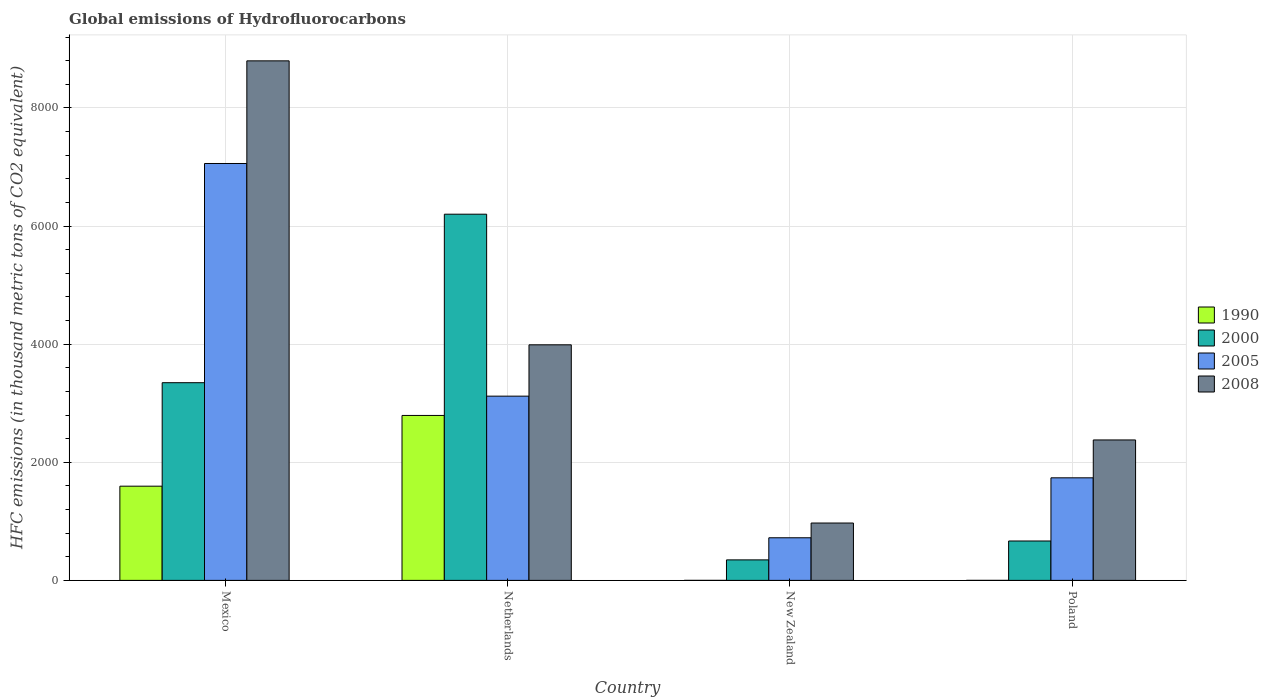How many groups of bars are there?
Offer a very short reply. 4. How many bars are there on the 2nd tick from the left?
Provide a short and direct response. 4. What is the label of the 3rd group of bars from the left?
Ensure brevity in your answer.  New Zealand. What is the global emissions of Hydrofluorocarbons in 2005 in Mexico?
Your answer should be very brief. 7058.9. Across all countries, what is the maximum global emissions of Hydrofluorocarbons in 1990?
Provide a succinct answer. 2792.9. Across all countries, what is the minimum global emissions of Hydrofluorocarbons in 2008?
Your answer should be compact. 971.4. What is the total global emissions of Hydrofluorocarbons in 2008 in the graph?
Your answer should be very brief. 1.61e+04. What is the difference between the global emissions of Hydrofluorocarbons in 2000 in Netherlands and that in New Zealand?
Make the answer very short. 5853.1. What is the difference between the global emissions of Hydrofluorocarbons in 2005 in Poland and the global emissions of Hydrofluorocarbons in 2000 in Mexico?
Your response must be concise. -1610.6. What is the average global emissions of Hydrofluorocarbons in 2008 per country?
Your response must be concise. 4033.78. What is the difference between the global emissions of Hydrofluorocarbons of/in 1990 and global emissions of Hydrofluorocarbons of/in 2008 in Mexico?
Your answer should be very brief. -7201.6. What is the ratio of the global emissions of Hydrofluorocarbons in 2005 in Mexico to that in Poland?
Ensure brevity in your answer.  4.06. Is the global emissions of Hydrofluorocarbons in 2008 in Netherlands less than that in Poland?
Your response must be concise. No. Is the difference between the global emissions of Hydrofluorocarbons in 1990 in Netherlands and Poland greater than the difference between the global emissions of Hydrofluorocarbons in 2008 in Netherlands and Poland?
Offer a very short reply. Yes. What is the difference between the highest and the second highest global emissions of Hydrofluorocarbons in 2008?
Provide a short and direct response. 1610.8. What is the difference between the highest and the lowest global emissions of Hydrofluorocarbons in 2005?
Offer a very short reply. 6337.2. What does the 1st bar from the left in Netherlands represents?
Offer a very short reply. 1990. What does the 4th bar from the right in New Zealand represents?
Give a very brief answer. 1990. Is it the case that in every country, the sum of the global emissions of Hydrofluorocarbons in 2000 and global emissions of Hydrofluorocarbons in 1990 is greater than the global emissions of Hydrofluorocarbons in 2005?
Provide a short and direct response. No. Are all the bars in the graph horizontal?
Your answer should be compact. No. How many countries are there in the graph?
Your answer should be compact. 4. What is the difference between two consecutive major ticks on the Y-axis?
Offer a terse response. 2000. Does the graph contain any zero values?
Make the answer very short. No. Where does the legend appear in the graph?
Provide a succinct answer. Center right. How many legend labels are there?
Give a very brief answer. 4. How are the legend labels stacked?
Your answer should be very brief. Vertical. What is the title of the graph?
Your answer should be compact. Global emissions of Hydrofluorocarbons. What is the label or title of the X-axis?
Provide a short and direct response. Country. What is the label or title of the Y-axis?
Give a very brief answer. HFC emissions (in thousand metric tons of CO2 equivalent). What is the HFC emissions (in thousand metric tons of CO2 equivalent) in 1990 in Mexico?
Your answer should be compact. 1595.3. What is the HFC emissions (in thousand metric tons of CO2 equivalent) in 2000 in Mexico?
Provide a succinct answer. 3347.3. What is the HFC emissions (in thousand metric tons of CO2 equivalent) of 2005 in Mexico?
Give a very brief answer. 7058.9. What is the HFC emissions (in thousand metric tons of CO2 equivalent) of 2008 in Mexico?
Give a very brief answer. 8796.9. What is the HFC emissions (in thousand metric tons of CO2 equivalent) in 1990 in Netherlands?
Ensure brevity in your answer.  2792.9. What is the HFC emissions (in thousand metric tons of CO2 equivalent) of 2000 in Netherlands?
Provide a short and direct response. 6200.4. What is the HFC emissions (in thousand metric tons of CO2 equivalent) of 2005 in Netherlands?
Give a very brief answer. 3119.5. What is the HFC emissions (in thousand metric tons of CO2 equivalent) of 2008 in Netherlands?
Give a very brief answer. 3988.8. What is the HFC emissions (in thousand metric tons of CO2 equivalent) in 2000 in New Zealand?
Your answer should be very brief. 347.3. What is the HFC emissions (in thousand metric tons of CO2 equivalent) of 2005 in New Zealand?
Provide a succinct answer. 721.7. What is the HFC emissions (in thousand metric tons of CO2 equivalent) in 2008 in New Zealand?
Provide a succinct answer. 971.4. What is the HFC emissions (in thousand metric tons of CO2 equivalent) of 2000 in Poland?
Your answer should be compact. 667.2. What is the HFC emissions (in thousand metric tons of CO2 equivalent) in 2005 in Poland?
Provide a succinct answer. 1736.7. What is the HFC emissions (in thousand metric tons of CO2 equivalent) in 2008 in Poland?
Your answer should be compact. 2378. Across all countries, what is the maximum HFC emissions (in thousand metric tons of CO2 equivalent) of 1990?
Your answer should be very brief. 2792.9. Across all countries, what is the maximum HFC emissions (in thousand metric tons of CO2 equivalent) of 2000?
Make the answer very short. 6200.4. Across all countries, what is the maximum HFC emissions (in thousand metric tons of CO2 equivalent) in 2005?
Offer a very short reply. 7058.9. Across all countries, what is the maximum HFC emissions (in thousand metric tons of CO2 equivalent) of 2008?
Your answer should be very brief. 8796.9. Across all countries, what is the minimum HFC emissions (in thousand metric tons of CO2 equivalent) in 1990?
Your answer should be compact. 0.1. Across all countries, what is the minimum HFC emissions (in thousand metric tons of CO2 equivalent) of 2000?
Your answer should be compact. 347.3. Across all countries, what is the minimum HFC emissions (in thousand metric tons of CO2 equivalent) in 2005?
Provide a succinct answer. 721.7. Across all countries, what is the minimum HFC emissions (in thousand metric tons of CO2 equivalent) in 2008?
Keep it short and to the point. 971.4. What is the total HFC emissions (in thousand metric tons of CO2 equivalent) of 1990 in the graph?
Provide a short and direct response. 4388.5. What is the total HFC emissions (in thousand metric tons of CO2 equivalent) of 2000 in the graph?
Keep it short and to the point. 1.06e+04. What is the total HFC emissions (in thousand metric tons of CO2 equivalent) of 2005 in the graph?
Provide a short and direct response. 1.26e+04. What is the total HFC emissions (in thousand metric tons of CO2 equivalent) in 2008 in the graph?
Your answer should be very brief. 1.61e+04. What is the difference between the HFC emissions (in thousand metric tons of CO2 equivalent) in 1990 in Mexico and that in Netherlands?
Your answer should be very brief. -1197.6. What is the difference between the HFC emissions (in thousand metric tons of CO2 equivalent) in 2000 in Mexico and that in Netherlands?
Keep it short and to the point. -2853.1. What is the difference between the HFC emissions (in thousand metric tons of CO2 equivalent) of 2005 in Mexico and that in Netherlands?
Give a very brief answer. 3939.4. What is the difference between the HFC emissions (in thousand metric tons of CO2 equivalent) of 2008 in Mexico and that in Netherlands?
Offer a terse response. 4808.1. What is the difference between the HFC emissions (in thousand metric tons of CO2 equivalent) in 1990 in Mexico and that in New Zealand?
Provide a succinct answer. 1595.1. What is the difference between the HFC emissions (in thousand metric tons of CO2 equivalent) in 2000 in Mexico and that in New Zealand?
Provide a short and direct response. 3000. What is the difference between the HFC emissions (in thousand metric tons of CO2 equivalent) of 2005 in Mexico and that in New Zealand?
Provide a short and direct response. 6337.2. What is the difference between the HFC emissions (in thousand metric tons of CO2 equivalent) in 2008 in Mexico and that in New Zealand?
Your response must be concise. 7825.5. What is the difference between the HFC emissions (in thousand metric tons of CO2 equivalent) of 1990 in Mexico and that in Poland?
Provide a succinct answer. 1595.2. What is the difference between the HFC emissions (in thousand metric tons of CO2 equivalent) in 2000 in Mexico and that in Poland?
Make the answer very short. 2680.1. What is the difference between the HFC emissions (in thousand metric tons of CO2 equivalent) of 2005 in Mexico and that in Poland?
Provide a short and direct response. 5322.2. What is the difference between the HFC emissions (in thousand metric tons of CO2 equivalent) of 2008 in Mexico and that in Poland?
Your response must be concise. 6418.9. What is the difference between the HFC emissions (in thousand metric tons of CO2 equivalent) of 1990 in Netherlands and that in New Zealand?
Offer a very short reply. 2792.7. What is the difference between the HFC emissions (in thousand metric tons of CO2 equivalent) of 2000 in Netherlands and that in New Zealand?
Offer a very short reply. 5853.1. What is the difference between the HFC emissions (in thousand metric tons of CO2 equivalent) of 2005 in Netherlands and that in New Zealand?
Your response must be concise. 2397.8. What is the difference between the HFC emissions (in thousand metric tons of CO2 equivalent) of 2008 in Netherlands and that in New Zealand?
Offer a very short reply. 3017.4. What is the difference between the HFC emissions (in thousand metric tons of CO2 equivalent) of 1990 in Netherlands and that in Poland?
Provide a short and direct response. 2792.8. What is the difference between the HFC emissions (in thousand metric tons of CO2 equivalent) in 2000 in Netherlands and that in Poland?
Ensure brevity in your answer.  5533.2. What is the difference between the HFC emissions (in thousand metric tons of CO2 equivalent) in 2005 in Netherlands and that in Poland?
Offer a very short reply. 1382.8. What is the difference between the HFC emissions (in thousand metric tons of CO2 equivalent) of 2008 in Netherlands and that in Poland?
Provide a short and direct response. 1610.8. What is the difference between the HFC emissions (in thousand metric tons of CO2 equivalent) of 1990 in New Zealand and that in Poland?
Provide a short and direct response. 0.1. What is the difference between the HFC emissions (in thousand metric tons of CO2 equivalent) in 2000 in New Zealand and that in Poland?
Your answer should be very brief. -319.9. What is the difference between the HFC emissions (in thousand metric tons of CO2 equivalent) in 2005 in New Zealand and that in Poland?
Your answer should be very brief. -1015. What is the difference between the HFC emissions (in thousand metric tons of CO2 equivalent) of 2008 in New Zealand and that in Poland?
Provide a short and direct response. -1406.6. What is the difference between the HFC emissions (in thousand metric tons of CO2 equivalent) of 1990 in Mexico and the HFC emissions (in thousand metric tons of CO2 equivalent) of 2000 in Netherlands?
Offer a very short reply. -4605.1. What is the difference between the HFC emissions (in thousand metric tons of CO2 equivalent) of 1990 in Mexico and the HFC emissions (in thousand metric tons of CO2 equivalent) of 2005 in Netherlands?
Make the answer very short. -1524.2. What is the difference between the HFC emissions (in thousand metric tons of CO2 equivalent) of 1990 in Mexico and the HFC emissions (in thousand metric tons of CO2 equivalent) of 2008 in Netherlands?
Offer a very short reply. -2393.5. What is the difference between the HFC emissions (in thousand metric tons of CO2 equivalent) of 2000 in Mexico and the HFC emissions (in thousand metric tons of CO2 equivalent) of 2005 in Netherlands?
Your answer should be very brief. 227.8. What is the difference between the HFC emissions (in thousand metric tons of CO2 equivalent) of 2000 in Mexico and the HFC emissions (in thousand metric tons of CO2 equivalent) of 2008 in Netherlands?
Provide a short and direct response. -641.5. What is the difference between the HFC emissions (in thousand metric tons of CO2 equivalent) of 2005 in Mexico and the HFC emissions (in thousand metric tons of CO2 equivalent) of 2008 in Netherlands?
Keep it short and to the point. 3070.1. What is the difference between the HFC emissions (in thousand metric tons of CO2 equivalent) of 1990 in Mexico and the HFC emissions (in thousand metric tons of CO2 equivalent) of 2000 in New Zealand?
Make the answer very short. 1248. What is the difference between the HFC emissions (in thousand metric tons of CO2 equivalent) in 1990 in Mexico and the HFC emissions (in thousand metric tons of CO2 equivalent) in 2005 in New Zealand?
Keep it short and to the point. 873.6. What is the difference between the HFC emissions (in thousand metric tons of CO2 equivalent) of 1990 in Mexico and the HFC emissions (in thousand metric tons of CO2 equivalent) of 2008 in New Zealand?
Offer a terse response. 623.9. What is the difference between the HFC emissions (in thousand metric tons of CO2 equivalent) of 2000 in Mexico and the HFC emissions (in thousand metric tons of CO2 equivalent) of 2005 in New Zealand?
Your answer should be compact. 2625.6. What is the difference between the HFC emissions (in thousand metric tons of CO2 equivalent) of 2000 in Mexico and the HFC emissions (in thousand metric tons of CO2 equivalent) of 2008 in New Zealand?
Your response must be concise. 2375.9. What is the difference between the HFC emissions (in thousand metric tons of CO2 equivalent) of 2005 in Mexico and the HFC emissions (in thousand metric tons of CO2 equivalent) of 2008 in New Zealand?
Ensure brevity in your answer.  6087.5. What is the difference between the HFC emissions (in thousand metric tons of CO2 equivalent) in 1990 in Mexico and the HFC emissions (in thousand metric tons of CO2 equivalent) in 2000 in Poland?
Offer a very short reply. 928.1. What is the difference between the HFC emissions (in thousand metric tons of CO2 equivalent) of 1990 in Mexico and the HFC emissions (in thousand metric tons of CO2 equivalent) of 2005 in Poland?
Your answer should be compact. -141.4. What is the difference between the HFC emissions (in thousand metric tons of CO2 equivalent) in 1990 in Mexico and the HFC emissions (in thousand metric tons of CO2 equivalent) in 2008 in Poland?
Provide a short and direct response. -782.7. What is the difference between the HFC emissions (in thousand metric tons of CO2 equivalent) of 2000 in Mexico and the HFC emissions (in thousand metric tons of CO2 equivalent) of 2005 in Poland?
Your answer should be compact. 1610.6. What is the difference between the HFC emissions (in thousand metric tons of CO2 equivalent) of 2000 in Mexico and the HFC emissions (in thousand metric tons of CO2 equivalent) of 2008 in Poland?
Give a very brief answer. 969.3. What is the difference between the HFC emissions (in thousand metric tons of CO2 equivalent) of 2005 in Mexico and the HFC emissions (in thousand metric tons of CO2 equivalent) of 2008 in Poland?
Offer a very short reply. 4680.9. What is the difference between the HFC emissions (in thousand metric tons of CO2 equivalent) in 1990 in Netherlands and the HFC emissions (in thousand metric tons of CO2 equivalent) in 2000 in New Zealand?
Your response must be concise. 2445.6. What is the difference between the HFC emissions (in thousand metric tons of CO2 equivalent) in 1990 in Netherlands and the HFC emissions (in thousand metric tons of CO2 equivalent) in 2005 in New Zealand?
Offer a very short reply. 2071.2. What is the difference between the HFC emissions (in thousand metric tons of CO2 equivalent) in 1990 in Netherlands and the HFC emissions (in thousand metric tons of CO2 equivalent) in 2008 in New Zealand?
Ensure brevity in your answer.  1821.5. What is the difference between the HFC emissions (in thousand metric tons of CO2 equivalent) in 2000 in Netherlands and the HFC emissions (in thousand metric tons of CO2 equivalent) in 2005 in New Zealand?
Make the answer very short. 5478.7. What is the difference between the HFC emissions (in thousand metric tons of CO2 equivalent) in 2000 in Netherlands and the HFC emissions (in thousand metric tons of CO2 equivalent) in 2008 in New Zealand?
Provide a succinct answer. 5229. What is the difference between the HFC emissions (in thousand metric tons of CO2 equivalent) in 2005 in Netherlands and the HFC emissions (in thousand metric tons of CO2 equivalent) in 2008 in New Zealand?
Make the answer very short. 2148.1. What is the difference between the HFC emissions (in thousand metric tons of CO2 equivalent) in 1990 in Netherlands and the HFC emissions (in thousand metric tons of CO2 equivalent) in 2000 in Poland?
Give a very brief answer. 2125.7. What is the difference between the HFC emissions (in thousand metric tons of CO2 equivalent) in 1990 in Netherlands and the HFC emissions (in thousand metric tons of CO2 equivalent) in 2005 in Poland?
Make the answer very short. 1056.2. What is the difference between the HFC emissions (in thousand metric tons of CO2 equivalent) of 1990 in Netherlands and the HFC emissions (in thousand metric tons of CO2 equivalent) of 2008 in Poland?
Provide a succinct answer. 414.9. What is the difference between the HFC emissions (in thousand metric tons of CO2 equivalent) of 2000 in Netherlands and the HFC emissions (in thousand metric tons of CO2 equivalent) of 2005 in Poland?
Provide a succinct answer. 4463.7. What is the difference between the HFC emissions (in thousand metric tons of CO2 equivalent) of 2000 in Netherlands and the HFC emissions (in thousand metric tons of CO2 equivalent) of 2008 in Poland?
Keep it short and to the point. 3822.4. What is the difference between the HFC emissions (in thousand metric tons of CO2 equivalent) in 2005 in Netherlands and the HFC emissions (in thousand metric tons of CO2 equivalent) in 2008 in Poland?
Offer a terse response. 741.5. What is the difference between the HFC emissions (in thousand metric tons of CO2 equivalent) of 1990 in New Zealand and the HFC emissions (in thousand metric tons of CO2 equivalent) of 2000 in Poland?
Keep it short and to the point. -667. What is the difference between the HFC emissions (in thousand metric tons of CO2 equivalent) in 1990 in New Zealand and the HFC emissions (in thousand metric tons of CO2 equivalent) in 2005 in Poland?
Ensure brevity in your answer.  -1736.5. What is the difference between the HFC emissions (in thousand metric tons of CO2 equivalent) of 1990 in New Zealand and the HFC emissions (in thousand metric tons of CO2 equivalent) of 2008 in Poland?
Make the answer very short. -2377.8. What is the difference between the HFC emissions (in thousand metric tons of CO2 equivalent) of 2000 in New Zealand and the HFC emissions (in thousand metric tons of CO2 equivalent) of 2005 in Poland?
Give a very brief answer. -1389.4. What is the difference between the HFC emissions (in thousand metric tons of CO2 equivalent) of 2000 in New Zealand and the HFC emissions (in thousand metric tons of CO2 equivalent) of 2008 in Poland?
Give a very brief answer. -2030.7. What is the difference between the HFC emissions (in thousand metric tons of CO2 equivalent) in 2005 in New Zealand and the HFC emissions (in thousand metric tons of CO2 equivalent) in 2008 in Poland?
Make the answer very short. -1656.3. What is the average HFC emissions (in thousand metric tons of CO2 equivalent) in 1990 per country?
Give a very brief answer. 1097.12. What is the average HFC emissions (in thousand metric tons of CO2 equivalent) of 2000 per country?
Your answer should be very brief. 2640.55. What is the average HFC emissions (in thousand metric tons of CO2 equivalent) of 2005 per country?
Ensure brevity in your answer.  3159.2. What is the average HFC emissions (in thousand metric tons of CO2 equivalent) of 2008 per country?
Make the answer very short. 4033.78. What is the difference between the HFC emissions (in thousand metric tons of CO2 equivalent) in 1990 and HFC emissions (in thousand metric tons of CO2 equivalent) in 2000 in Mexico?
Your answer should be compact. -1752. What is the difference between the HFC emissions (in thousand metric tons of CO2 equivalent) of 1990 and HFC emissions (in thousand metric tons of CO2 equivalent) of 2005 in Mexico?
Your answer should be very brief. -5463.6. What is the difference between the HFC emissions (in thousand metric tons of CO2 equivalent) of 1990 and HFC emissions (in thousand metric tons of CO2 equivalent) of 2008 in Mexico?
Your response must be concise. -7201.6. What is the difference between the HFC emissions (in thousand metric tons of CO2 equivalent) in 2000 and HFC emissions (in thousand metric tons of CO2 equivalent) in 2005 in Mexico?
Offer a terse response. -3711.6. What is the difference between the HFC emissions (in thousand metric tons of CO2 equivalent) of 2000 and HFC emissions (in thousand metric tons of CO2 equivalent) of 2008 in Mexico?
Give a very brief answer. -5449.6. What is the difference between the HFC emissions (in thousand metric tons of CO2 equivalent) of 2005 and HFC emissions (in thousand metric tons of CO2 equivalent) of 2008 in Mexico?
Your answer should be very brief. -1738. What is the difference between the HFC emissions (in thousand metric tons of CO2 equivalent) of 1990 and HFC emissions (in thousand metric tons of CO2 equivalent) of 2000 in Netherlands?
Offer a very short reply. -3407.5. What is the difference between the HFC emissions (in thousand metric tons of CO2 equivalent) of 1990 and HFC emissions (in thousand metric tons of CO2 equivalent) of 2005 in Netherlands?
Your response must be concise. -326.6. What is the difference between the HFC emissions (in thousand metric tons of CO2 equivalent) in 1990 and HFC emissions (in thousand metric tons of CO2 equivalent) in 2008 in Netherlands?
Offer a terse response. -1195.9. What is the difference between the HFC emissions (in thousand metric tons of CO2 equivalent) of 2000 and HFC emissions (in thousand metric tons of CO2 equivalent) of 2005 in Netherlands?
Your answer should be very brief. 3080.9. What is the difference between the HFC emissions (in thousand metric tons of CO2 equivalent) in 2000 and HFC emissions (in thousand metric tons of CO2 equivalent) in 2008 in Netherlands?
Ensure brevity in your answer.  2211.6. What is the difference between the HFC emissions (in thousand metric tons of CO2 equivalent) of 2005 and HFC emissions (in thousand metric tons of CO2 equivalent) of 2008 in Netherlands?
Make the answer very short. -869.3. What is the difference between the HFC emissions (in thousand metric tons of CO2 equivalent) in 1990 and HFC emissions (in thousand metric tons of CO2 equivalent) in 2000 in New Zealand?
Offer a very short reply. -347.1. What is the difference between the HFC emissions (in thousand metric tons of CO2 equivalent) in 1990 and HFC emissions (in thousand metric tons of CO2 equivalent) in 2005 in New Zealand?
Ensure brevity in your answer.  -721.5. What is the difference between the HFC emissions (in thousand metric tons of CO2 equivalent) in 1990 and HFC emissions (in thousand metric tons of CO2 equivalent) in 2008 in New Zealand?
Ensure brevity in your answer.  -971.2. What is the difference between the HFC emissions (in thousand metric tons of CO2 equivalent) of 2000 and HFC emissions (in thousand metric tons of CO2 equivalent) of 2005 in New Zealand?
Provide a short and direct response. -374.4. What is the difference between the HFC emissions (in thousand metric tons of CO2 equivalent) in 2000 and HFC emissions (in thousand metric tons of CO2 equivalent) in 2008 in New Zealand?
Keep it short and to the point. -624.1. What is the difference between the HFC emissions (in thousand metric tons of CO2 equivalent) of 2005 and HFC emissions (in thousand metric tons of CO2 equivalent) of 2008 in New Zealand?
Make the answer very short. -249.7. What is the difference between the HFC emissions (in thousand metric tons of CO2 equivalent) of 1990 and HFC emissions (in thousand metric tons of CO2 equivalent) of 2000 in Poland?
Give a very brief answer. -667.1. What is the difference between the HFC emissions (in thousand metric tons of CO2 equivalent) in 1990 and HFC emissions (in thousand metric tons of CO2 equivalent) in 2005 in Poland?
Make the answer very short. -1736.6. What is the difference between the HFC emissions (in thousand metric tons of CO2 equivalent) in 1990 and HFC emissions (in thousand metric tons of CO2 equivalent) in 2008 in Poland?
Make the answer very short. -2377.9. What is the difference between the HFC emissions (in thousand metric tons of CO2 equivalent) of 2000 and HFC emissions (in thousand metric tons of CO2 equivalent) of 2005 in Poland?
Your response must be concise. -1069.5. What is the difference between the HFC emissions (in thousand metric tons of CO2 equivalent) of 2000 and HFC emissions (in thousand metric tons of CO2 equivalent) of 2008 in Poland?
Your answer should be very brief. -1710.8. What is the difference between the HFC emissions (in thousand metric tons of CO2 equivalent) in 2005 and HFC emissions (in thousand metric tons of CO2 equivalent) in 2008 in Poland?
Offer a very short reply. -641.3. What is the ratio of the HFC emissions (in thousand metric tons of CO2 equivalent) of 1990 in Mexico to that in Netherlands?
Your answer should be very brief. 0.57. What is the ratio of the HFC emissions (in thousand metric tons of CO2 equivalent) in 2000 in Mexico to that in Netherlands?
Your answer should be compact. 0.54. What is the ratio of the HFC emissions (in thousand metric tons of CO2 equivalent) of 2005 in Mexico to that in Netherlands?
Keep it short and to the point. 2.26. What is the ratio of the HFC emissions (in thousand metric tons of CO2 equivalent) of 2008 in Mexico to that in Netherlands?
Keep it short and to the point. 2.21. What is the ratio of the HFC emissions (in thousand metric tons of CO2 equivalent) of 1990 in Mexico to that in New Zealand?
Your answer should be compact. 7976.5. What is the ratio of the HFC emissions (in thousand metric tons of CO2 equivalent) in 2000 in Mexico to that in New Zealand?
Your response must be concise. 9.64. What is the ratio of the HFC emissions (in thousand metric tons of CO2 equivalent) of 2005 in Mexico to that in New Zealand?
Make the answer very short. 9.78. What is the ratio of the HFC emissions (in thousand metric tons of CO2 equivalent) of 2008 in Mexico to that in New Zealand?
Provide a short and direct response. 9.06. What is the ratio of the HFC emissions (in thousand metric tons of CO2 equivalent) of 1990 in Mexico to that in Poland?
Your answer should be compact. 1.60e+04. What is the ratio of the HFC emissions (in thousand metric tons of CO2 equivalent) in 2000 in Mexico to that in Poland?
Offer a terse response. 5.02. What is the ratio of the HFC emissions (in thousand metric tons of CO2 equivalent) of 2005 in Mexico to that in Poland?
Provide a short and direct response. 4.06. What is the ratio of the HFC emissions (in thousand metric tons of CO2 equivalent) of 2008 in Mexico to that in Poland?
Offer a very short reply. 3.7. What is the ratio of the HFC emissions (in thousand metric tons of CO2 equivalent) of 1990 in Netherlands to that in New Zealand?
Provide a short and direct response. 1.40e+04. What is the ratio of the HFC emissions (in thousand metric tons of CO2 equivalent) of 2000 in Netherlands to that in New Zealand?
Your answer should be very brief. 17.85. What is the ratio of the HFC emissions (in thousand metric tons of CO2 equivalent) of 2005 in Netherlands to that in New Zealand?
Your answer should be very brief. 4.32. What is the ratio of the HFC emissions (in thousand metric tons of CO2 equivalent) of 2008 in Netherlands to that in New Zealand?
Make the answer very short. 4.11. What is the ratio of the HFC emissions (in thousand metric tons of CO2 equivalent) of 1990 in Netherlands to that in Poland?
Provide a succinct answer. 2.79e+04. What is the ratio of the HFC emissions (in thousand metric tons of CO2 equivalent) of 2000 in Netherlands to that in Poland?
Offer a terse response. 9.29. What is the ratio of the HFC emissions (in thousand metric tons of CO2 equivalent) in 2005 in Netherlands to that in Poland?
Give a very brief answer. 1.8. What is the ratio of the HFC emissions (in thousand metric tons of CO2 equivalent) of 2008 in Netherlands to that in Poland?
Offer a very short reply. 1.68. What is the ratio of the HFC emissions (in thousand metric tons of CO2 equivalent) of 2000 in New Zealand to that in Poland?
Ensure brevity in your answer.  0.52. What is the ratio of the HFC emissions (in thousand metric tons of CO2 equivalent) in 2005 in New Zealand to that in Poland?
Provide a short and direct response. 0.42. What is the ratio of the HFC emissions (in thousand metric tons of CO2 equivalent) of 2008 in New Zealand to that in Poland?
Ensure brevity in your answer.  0.41. What is the difference between the highest and the second highest HFC emissions (in thousand metric tons of CO2 equivalent) of 1990?
Your response must be concise. 1197.6. What is the difference between the highest and the second highest HFC emissions (in thousand metric tons of CO2 equivalent) in 2000?
Your response must be concise. 2853.1. What is the difference between the highest and the second highest HFC emissions (in thousand metric tons of CO2 equivalent) in 2005?
Provide a short and direct response. 3939.4. What is the difference between the highest and the second highest HFC emissions (in thousand metric tons of CO2 equivalent) of 2008?
Ensure brevity in your answer.  4808.1. What is the difference between the highest and the lowest HFC emissions (in thousand metric tons of CO2 equivalent) of 1990?
Provide a succinct answer. 2792.8. What is the difference between the highest and the lowest HFC emissions (in thousand metric tons of CO2 equivalent) of 2000?
Offer a very short reply. 5853.1. What is the difference between the highest and the lowest HFC emissions (in thousand metric tons of CO2 equivalent) in 2005?
Your answer should be compact. 6337.2. What is the difference between the highest and the lowest HFC emissions (in thousand metric tons of CO2 equivalent) in 2008?
Offer a terse response. 7825.5. 